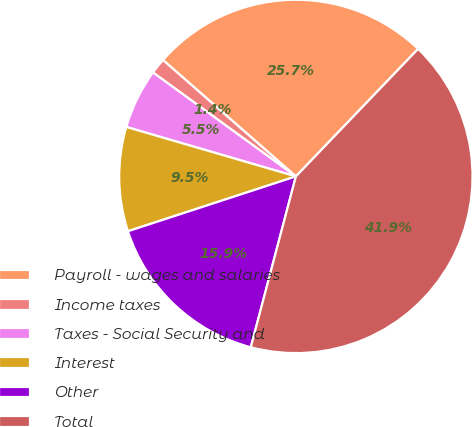<chart> <loc_0><loc_0><loc_500><loc_500><pie_chart><fcel>Payroll - wages and salaries<fcel>Income taxes<fcel>Taxes - Social Security and<fcel>Interest<fcel>Other<fcel>Total<nl><fcel>25.71%<fcel>1.44%<fcel>5.49%<fcel>9.54%<fcel>15.87%<fcel>41.94%<nl></chart> 